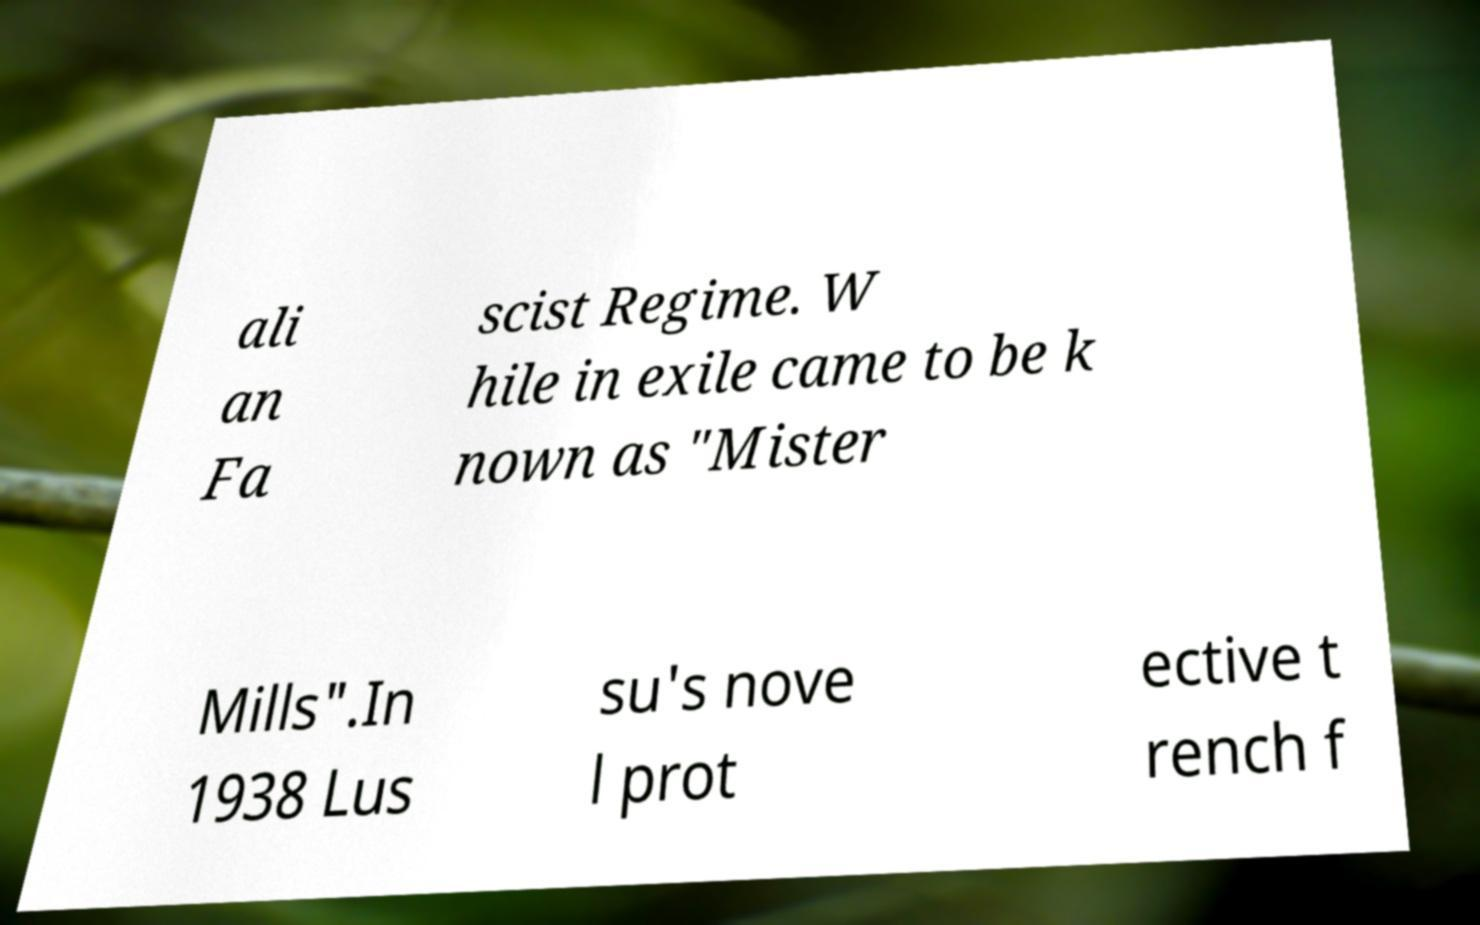There's text embedded in this image that I need extracted. Can you transcribe it verbatim? ali an Fa scist Regime. W hile in exile came to be k nown as "Mister Mills".In 1938 Lus su's nove l prot ective t rench f 